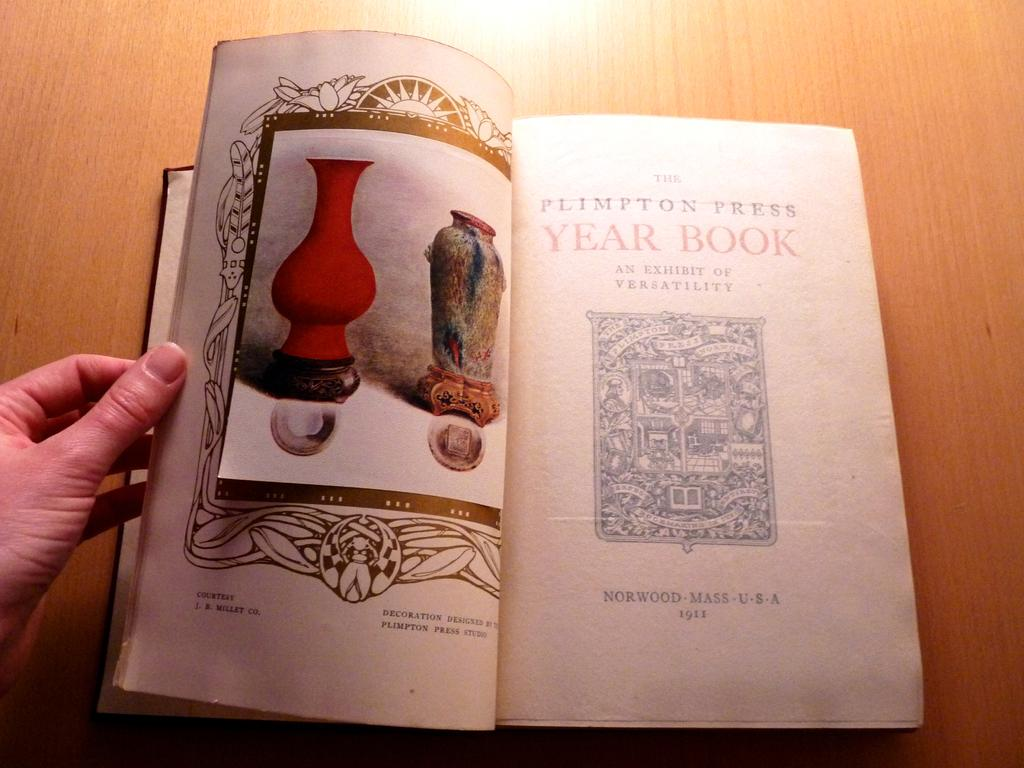<image>
Present a compact description of the photo's key features. A copy of The Plimpton Press Year Book from 1911 is held open on a table. 